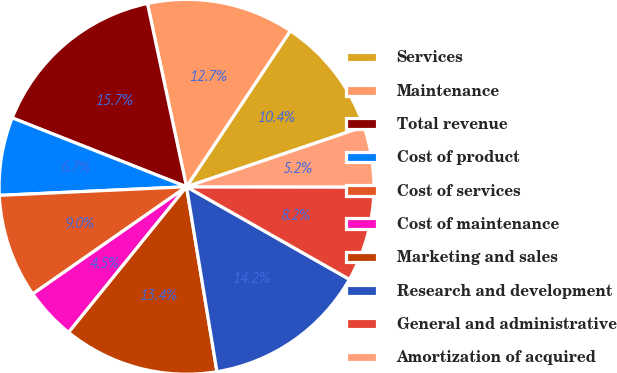Convert chart to OTSL. <chart><loc_0><loc_0><loc_500><loc_500><pie_chart><fcel>Services<fcel>Maintenance<fcel>Total revenue<fcel>Cost of product<fcel>Cost of services<fcel>Cost of maintenance<fcel>Marketing and sales<fcel>Research and development<fcel>General and administrative<fcel>Amortization of acquired<nl><fcel>10.45%<fcel>12.69%<fcel>15.67%<fcel>6.72%<fcel>8.96%<fcel>4.48%<fcel>13.43%<fcel>14.18%<fcel>8.21%<fcel>5.22%<nl></chart> 